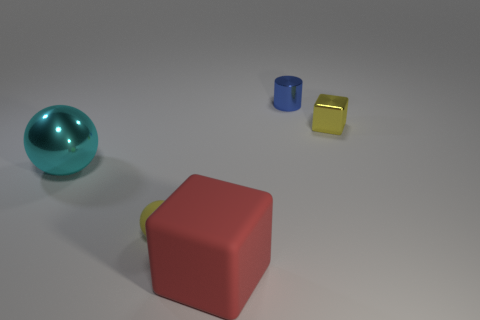Add 4 shiny cylinders. How many objects exist? 9 Subtract all spheres. How many objects are left? 3 Subtract all yellow rubber spheres. Subtract all big cyan metal spheres. How many objects are left? 3 Add 5 small yellow objects. How many small yellow objects are left? 7 Add 1 tiny blue blocks. How many tiny blue blocks exist? 1 Subtract 0 yellow cylinders. How many objects are left? 5 